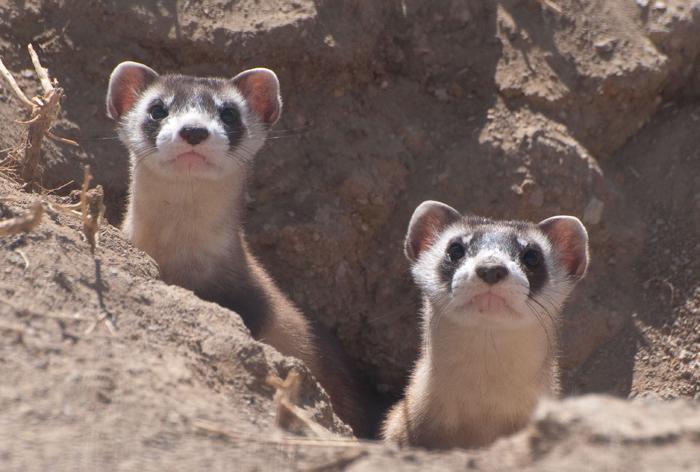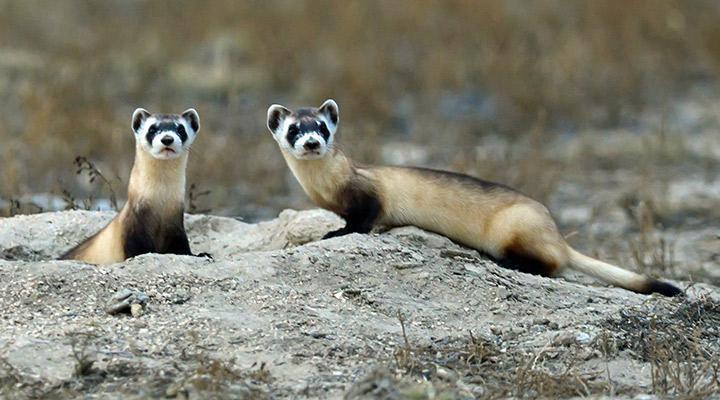The first image is the image on the left, the second image is the image on the right. For the images displayed, is the sentence "There are two animals" factually correct? Answer yes or no. No. The first image is the image on the left, the second image is the image on the right. Evaluate the accuracy of this statement regarding the images: "Each image contains exactly one animal.". Is it true? Answer yes or no. No. 